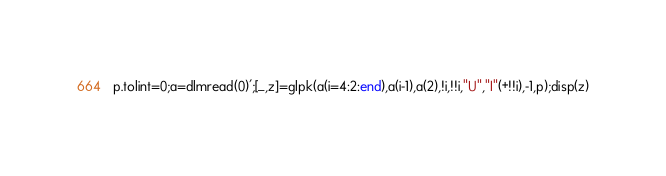<code> <loc_0><loc_0><loc_500><loc_500><_Octave_>p.tolint=0;a=dlmread(0)';[_,z]=glpk(a(i=4:2:end),a(i-1),a(2),!i,!!i,"U","I"(+!!i),-1,p);disp(z)</code> 